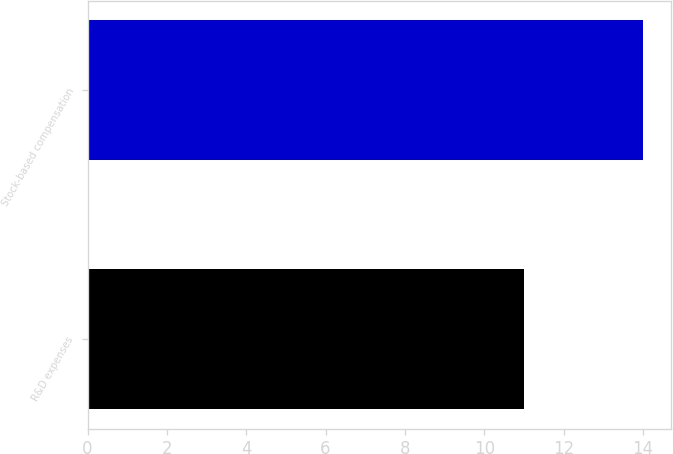Convert chart. <chart><loc_0><loc_0><loc_500><loc_500><bar_chart><fcel>R&D expenses<fcel>Stock-based compensation<nl><fcel>11<fcel>14<nl></chart> 